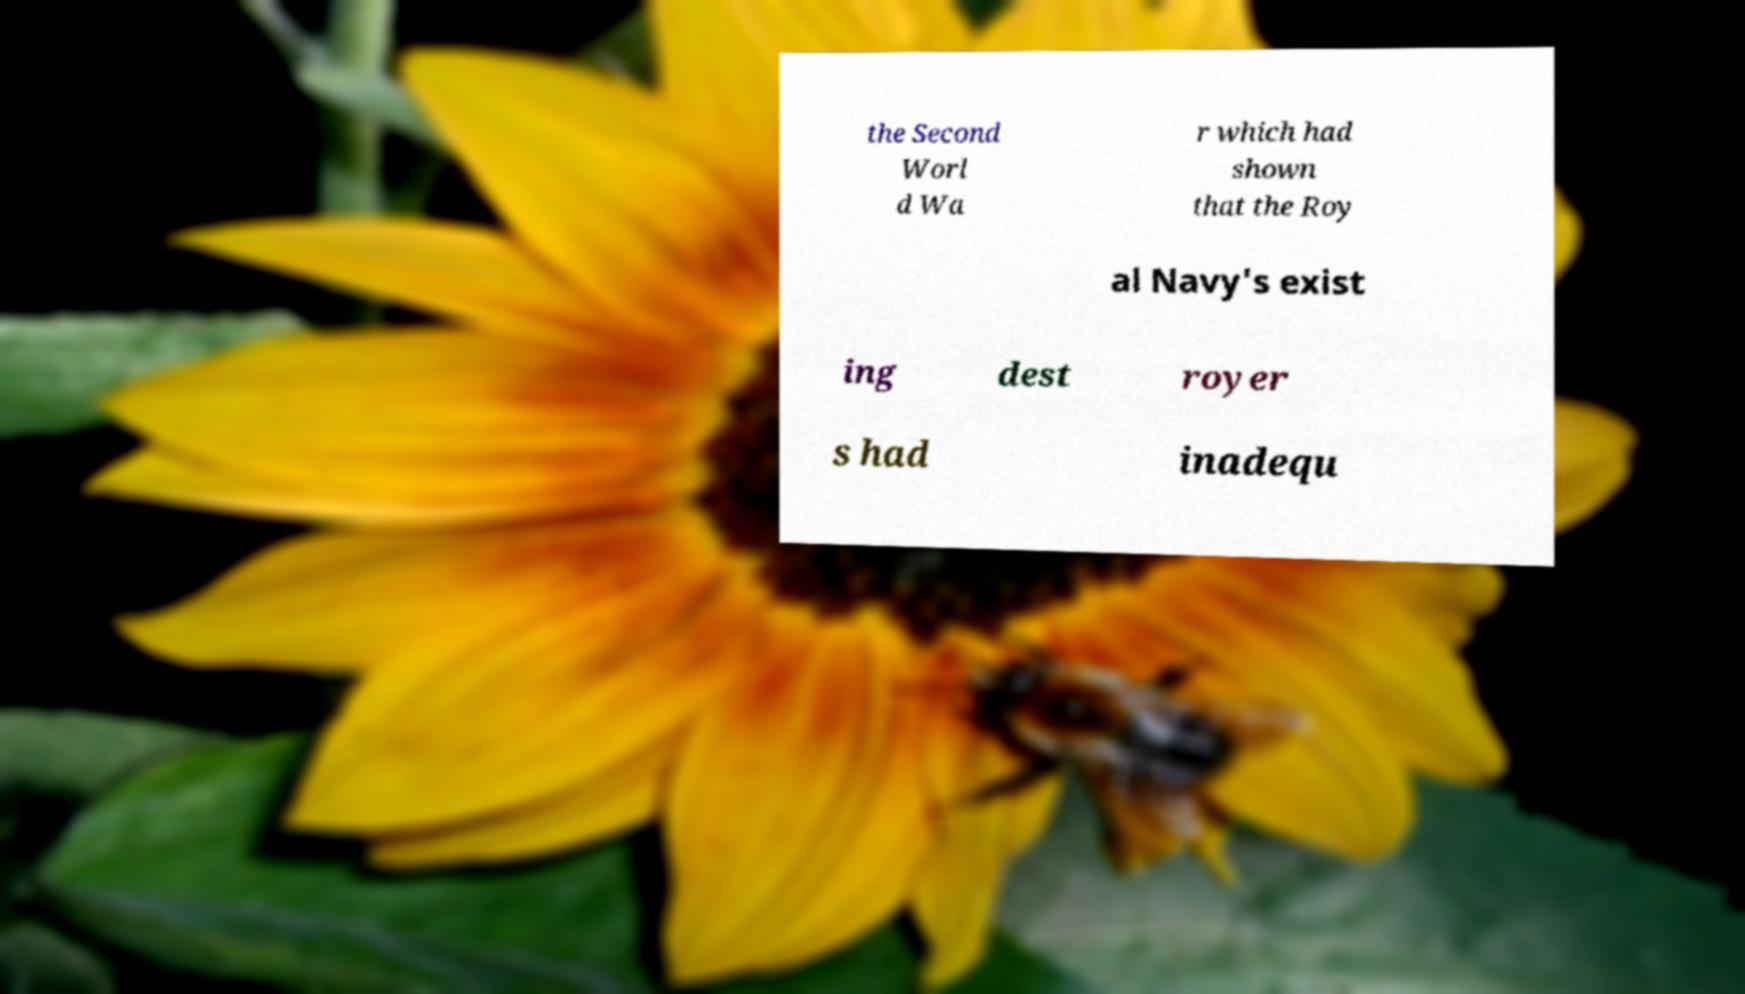Could you extract and type out the text from this image? the Second Worl d Wa r which had shown that the Roy al Navy's exist ing dest royer s had inadequ 